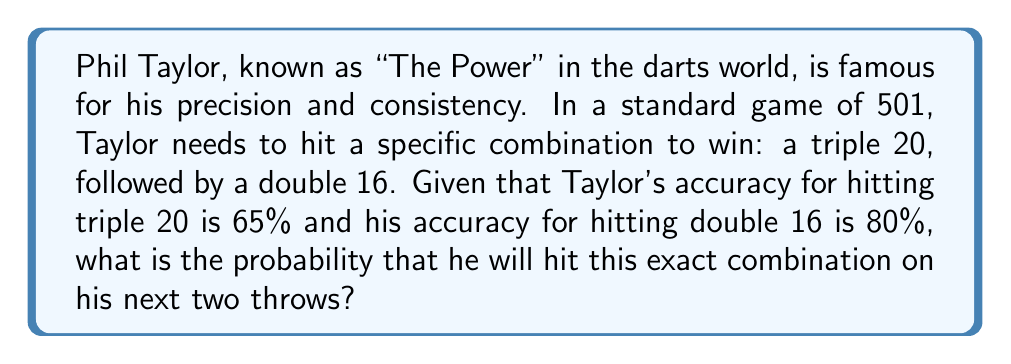Show me your answer to this math problem. To solve this problem, we need to apply the concept of independent events and multiply their probabilities.

1) The probability of hitting triple 20 is given as 65% or 0.65.

2) The probability of hitting double 16 is given as 80% or 0.80.

3) For Taylor to hit this exact combination, he needs to succeed in both throws. These are independent events, meaning the outcome of one does not affect the other.

4) To find the probability of both events occurring, we multiply their individual probabilities:

   $$P(\text{triple 20 AND double 16}) = P(\text{triple 20}) \times P(\text{double 16})$$

5) Substituting the given probabilities:

   $$P(\text{triple 20 AND double 16}) = 0.65 \times 0.80$$

6) Calculating:

   $$P(\text{triple 20 AND double 16}) = 0.52$$

7) Converting to a percentage:

   $$0.52 \times 100\% = 52\%$$

Therefore, the probability that Phil Taylor will hit this exact combination on his next two throws is 52%.
Answer: 52% 